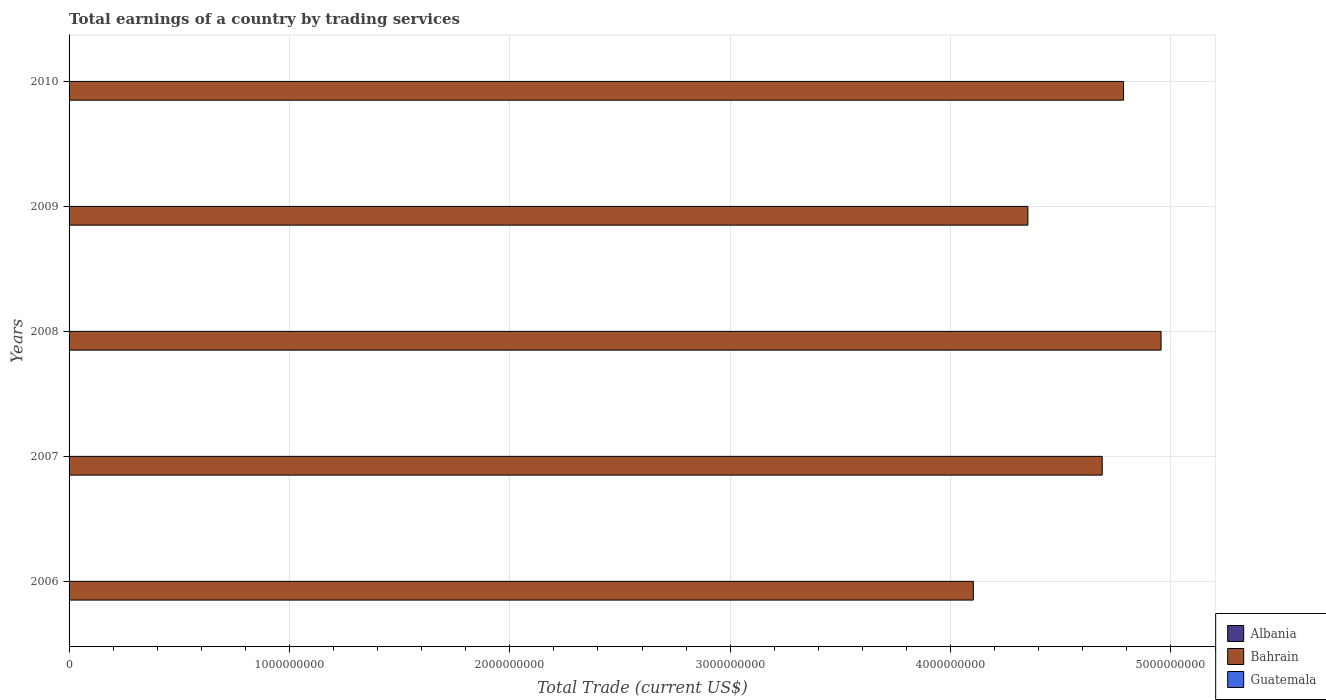Are the number of bars per tick equal to the number of legend labels?
Keep it short and to the point. No. Are the number of bars on each tick of the Y-axis equal?
Provide a succinct answer. Yes. What is the label of the 1st group of bars from the top?
Provide a succinct answer. 2010. In how many cases, is the number of bars for a given year not equal to the number of legend labels?
Your answer should be very brief. 5. What is the total earnings in Guatemala in 2009?
Your answer should be compact. 0. Across all years, what is the maximum total earnings in Bahrain?
Give a very brief answer. 4.96e+09. Across all years, what is the minimum total earnings in Guatemala?
Your answer should be very brief. 0. In which year was the total earnings in Bahrain maximum?
Your answer should be compact. 2008. What is the difference between the total earnings in Bahrain in 2009 and that in 2010?
Provide a short and direct response. -4.34e+08. What is the difference between the total earnings in Albania in 2009 and the total earnings in Guatemala in 2007?
Your answer should be very brief. 0. What is the ratio of the total earnings in Bahrain in 2007 to that in 2008?
Provide a succinct answer. 0.95. What is the difference between the highest and the second highest total earnings in Bahrain?
Keep it short and to the point. 1.70e+08. What is the difference between the highest and the lowest total earnings in Bahrain?
Provide a succinct answer. 8.52e+08. Is the sum of the total earnings in Bahrain in 2006 and 2007 greater than the maximum total earnings in Albania across all years?
Offer a very short reply. Yes. Is it the case that in every year, the sum of the total earnings in Bahrain and total earnings in Guatemala is greater than the total earnings in Albania?
Keep it short and to the point. Yes. How many bars are there?
Make the answer very short. 5. Are all the bars in the graph horizontal?
Provide a succinct answer. Yes. How many years are there in the graph?
Provide a short and direct response. 5. Are the values on the major ticks of X-axis written in scientific E-notation?
Provide a succinct answer. No. Does the graph contain any zero values?
Offer a terse response. Yes. How are the legend labels stacked?
Your answer should be very brief. Vertical. What is the title of the graph?
Offer a very short reply. Total earnings of a country by trading services. What is the label or title of the X-axis?
Ensure brevity in your answer.  Total Trade (current US$). What is the Total Trade (current US$) in Bahrain in 2006?
Your answer should be compact. 4.10e+09. What is the Total Trade (current US$) of Guatemala in 2006?
Offer a terse response. 0. What is the Total Trade (current US$) of Bahrain in 2007?
Keep it short and to the point. 4.69e+09. What is the Total Trade (current US$) in Guatemala in 2007?
Your response must be concise. 0. What is the Total Trade (current US$) in Bahrain in 2008?
Make the answer very short. 4.96e+09. What is the Total Trade (current US$) in Guatemala in 2008?
Give a very brief answer. 0. What is the Total Trade (current US$) in Bahrain in 2009?
Your answer should be very brief. 4.35e+09. What is the Total Trade (current US$) of Albania in 2010?
Make the answer very short. 0. What is the Total Trade (current US$) of Bahrain in 2010?
Your answer should be compact. 4.78e+09. What is the Total Trade (current US$) of Guatemala in 2010?
Provide a short and direct response. 0. Across all years, what is the maximum Total Trade (current US$) of Bahrain?
Give a very brief answer. 4.96e+09. Across all years, what is the minimum Total Trade (current US$) in Bahrain?
Ensure brevity in your answer.  4.10e+09. What is the total Total Trade (current US$) in Albania in the graph?
Provide a succinct answer. 0. What is the total Total Trade (current US$) in Bahrain in the graph?
Your response must be concise. 2.29e+1. What is the total Total Trade (current US$) of Guatemala in the graph?
Your response must be concise. 0. What is the difference between the Total Trade (current US$) of Bahrain in 2006 and that in 2007?
Offer a terse response. -5.85e+08. What is the difference between the Total Trade (current US$) in Bahrain in 2006 and that in 2008?
Offer a very short reply. -8.52e+08. What is the difference between the Total Trade (current US$) in Bahrain in 2006 and that in 2009?
Your answer should be compact. -2.48e+08. What is the difference between the Total Trade (current US$) of Bahrain in 2006 and that in 2010?
Give a very brief answer. -6.82e+08. What is the difference between the Total Trade (current US$) of Bahrain in 2007 and that in 2008?
Make the answer very short. -2.67e+08. What is the difference between the Total Trade (current US$) in Bahrain in 2007 and that in 2009?
Your response must be concise. 3.37e+08. What is the difference between the Total Trade (current US$) of Bahrain in 2007 and that in 2010?
Your answer should be very brief. -9.68e+07. What is the difference between the Total Trade (current US$) in Bahrain in 2008 and that in 2009?
Give a very brief answer. 6.04e+08. What is the difference between the Total Trade (current US$) of Bahrain in 2008 and that in 2010?
Provide a short and direct response. 1.70e+08. What is the difference between the Total Trade (current US$) in Bahrain in 2009 and that in 2010?
Provide a short and direct response. -4.34e+08. What is the average Total Trade (current US$) of Albania per year?
Provide a short and direct response. 0. What is the average Total Trade (current US$) of Bahrain per year?
Provide a short and direct response. 4.58e+09. What is the ratio of the Total Trade (current US$) in Bahrain in 2006 to that in 2007?
Your answer should be compact. 0.88. What is the ratio of the Total Trade (current US$) of Bahrain in 2006 to that in 2008?
Your answer should be very brief. 0.83. What is the ratio of the Total Trade (current US$) of Bahrain in 2006 to that in 2009?
Make the answer very short. 0.94. What is the ratio of the Total Trade (current US$) in Bahrain in 2006 to that in 2010?
Offer a very short reply. 0.86. What is the ratio of the Total Trade (current US$) in Bahrain in 2007 to that in 2008?
Provide a succinct answer. 0.95. What is the ratio of the Total Trade (current US$) of Bahrain in 2007 to that in 2009?
Provide a succinct answer. 1.08. What is the ratio of the Total Trade (current US$) in Bahrain in 2007 to that in 2010?
Keep it short and to the point. 0.98. What is the ratio of the Total Trade (current US$) of Bahrain in 2008 to that in 2009?
Ensure brevity in your answer.  1.14. What is the ratio of the Total Trade (current US$) of Bahrain in 2008 to that in 2010?
Your answer should be compact. 1.04. What is the ratio of the Total Trade (current US$) in Bahrain in 2009 to that in 2010?
Ensure brevity in your answer.  0.91. What is the difference between the highest and the second highest Total Trade (current US$) of Bahrain?
Provide a succinct answer. 1.70e+08. What is the difference between the highest and the lowest Total Trade (current US$) in Bahrain?
Your response must be concise. 8.52e+08. 